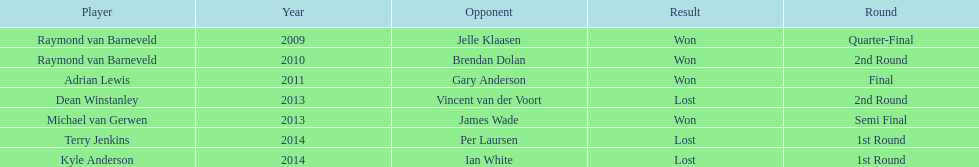Who was the last to win against his opponent? Michael van Gerwen. 